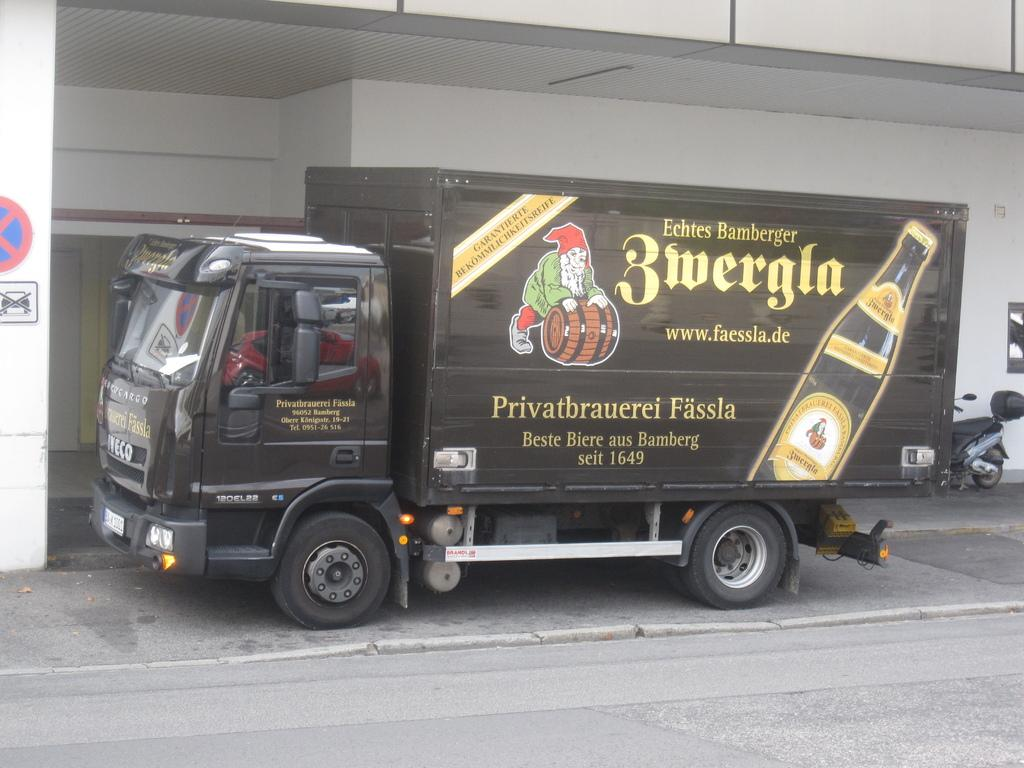What is the main vehicle in the image? There is a truck in the image. What can be seen on the truck? The truck has pictures and text on it. What other vehicle is present in the image? There is a motorbike parked in the image. What is on the wall in the image? There is a signboard on a wall in the image. What structure is visible in the image? There is a roof visible in the image. How many bikes are being ridden by the people in the image? There are no bikes being ridden by people in the image; there is only a parked motorbike. 